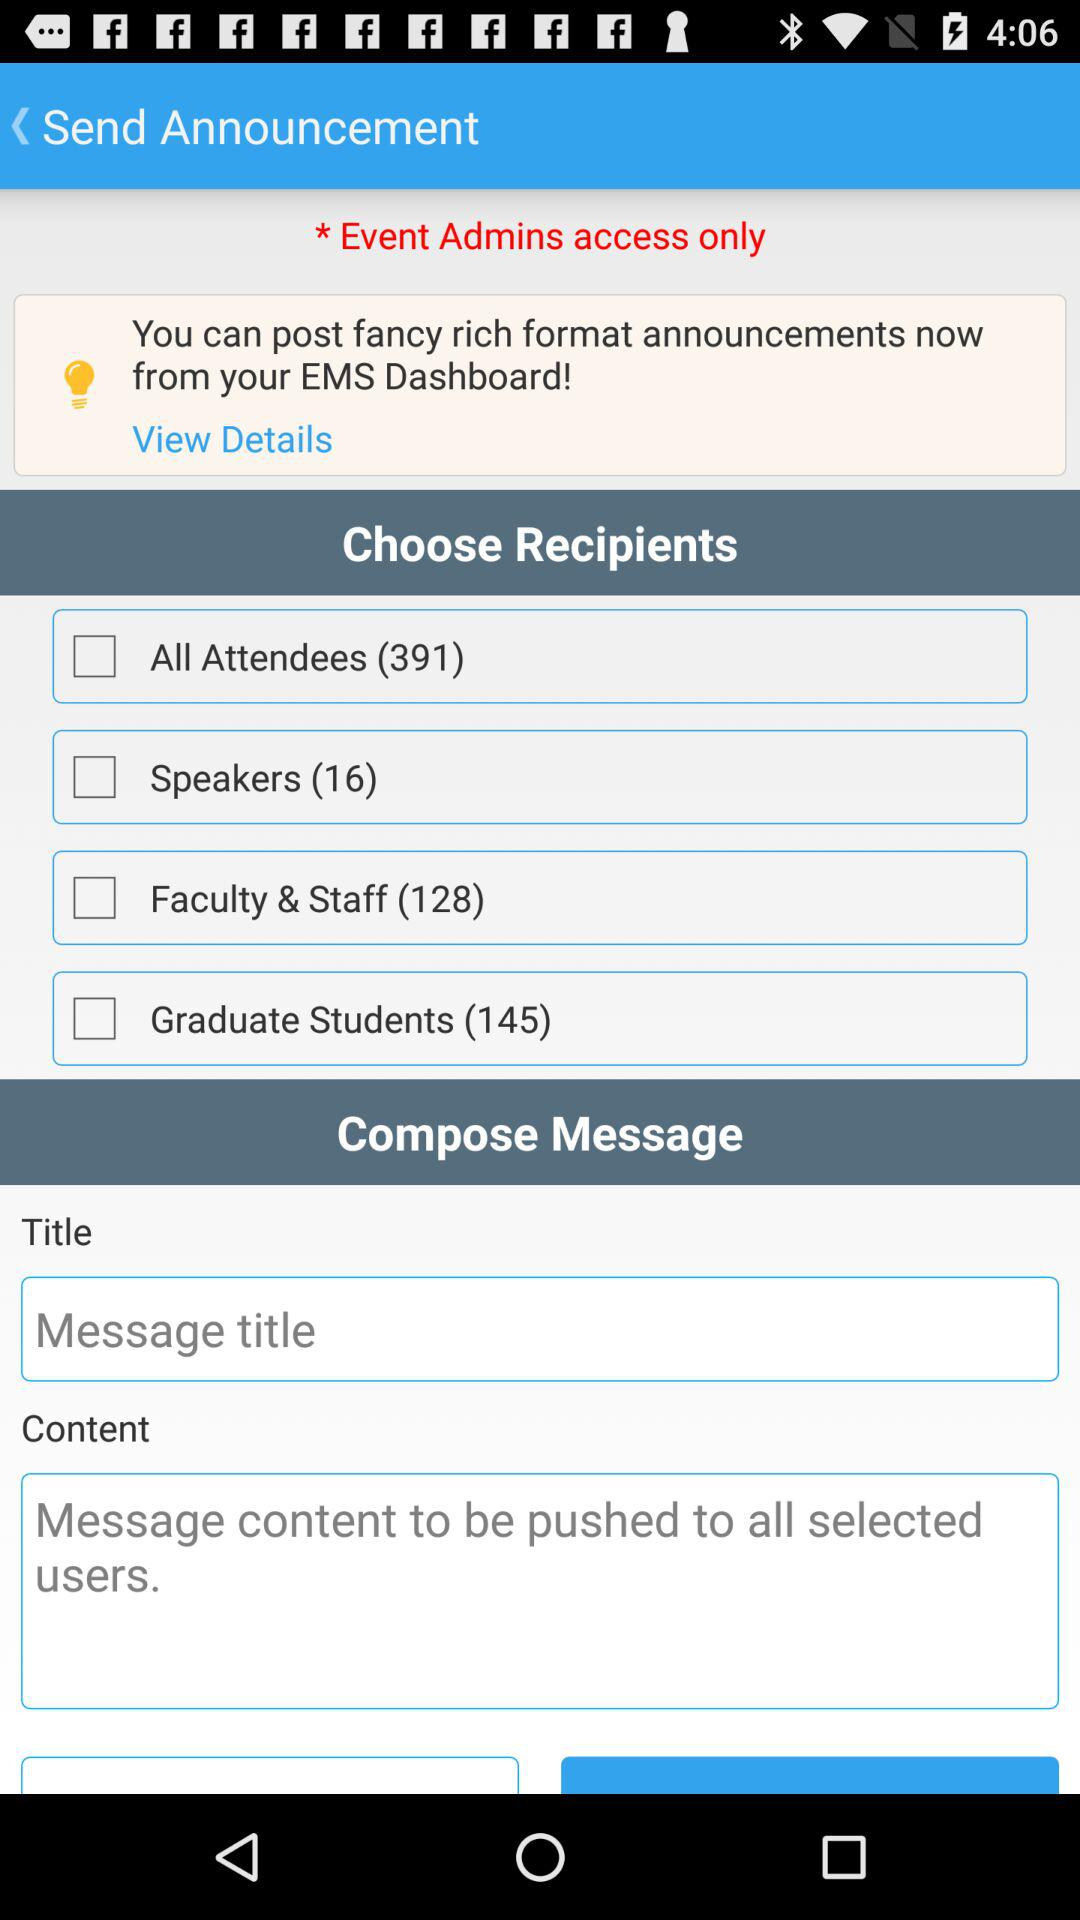How many people are there in "Faculty & Staff"? There are 128 people in "Faculty & Staff". 